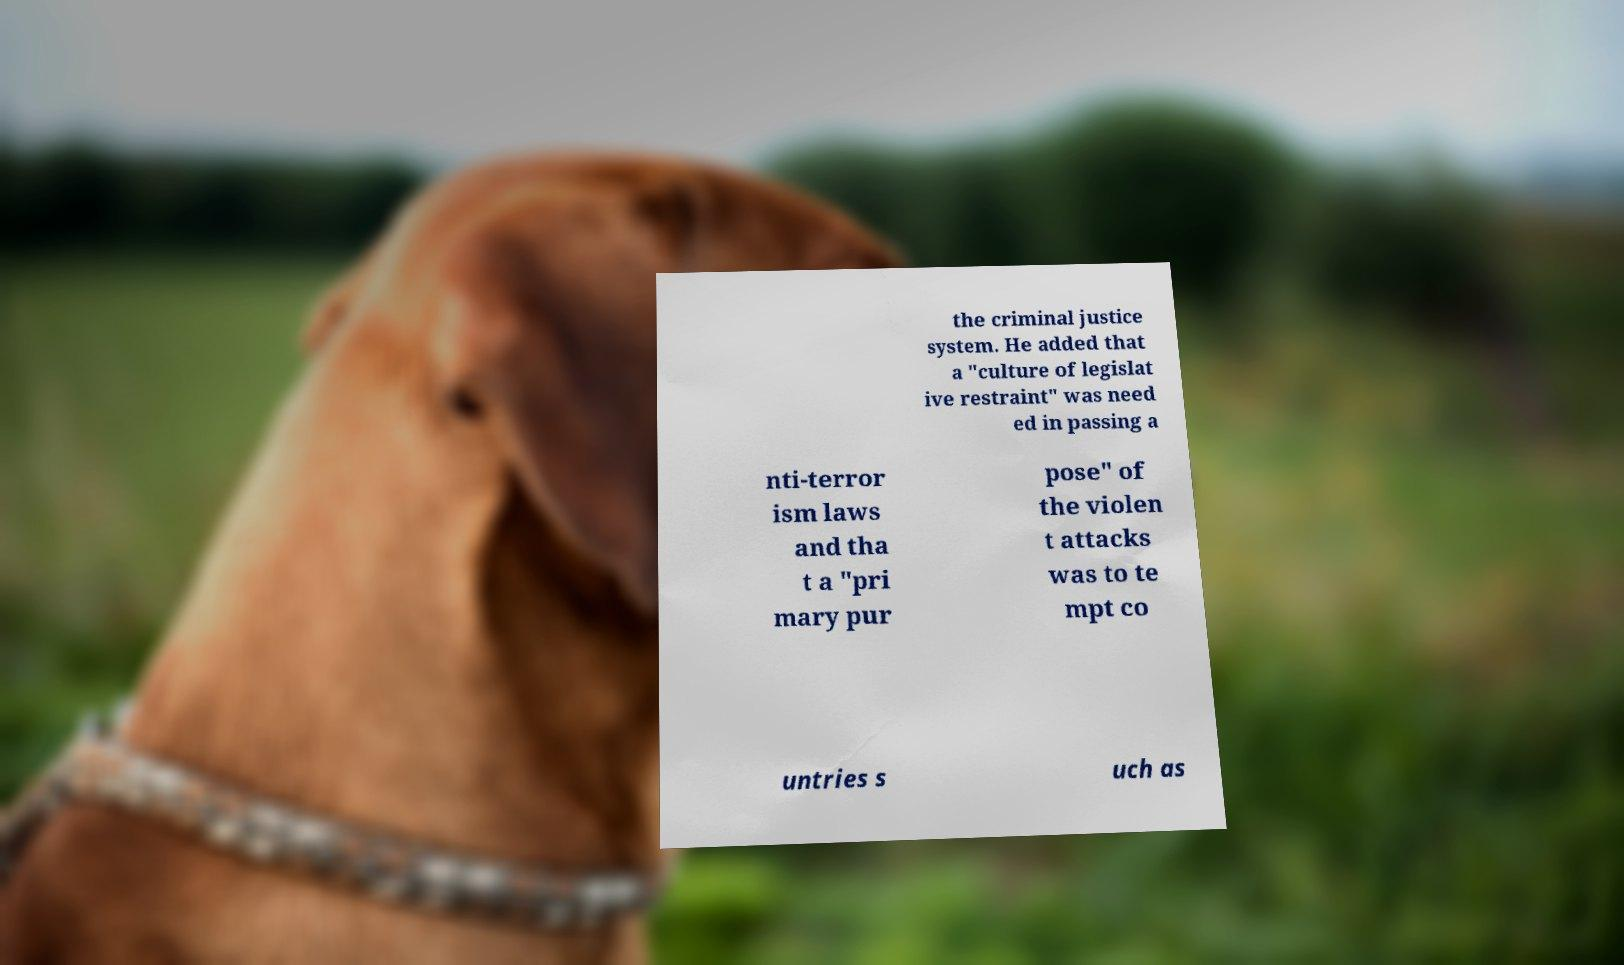Can you read and provide the text displayed in the image?This photo seems to have some interesting text. Can you extract and type it out for me? the criminal justice system. He added that a "culture of legislat ive restraint" was need ed in passing a nti-terror ism laws and tha t a "pri mary pur pose" of the violen t attacks was to te mpt co untries s uch as 